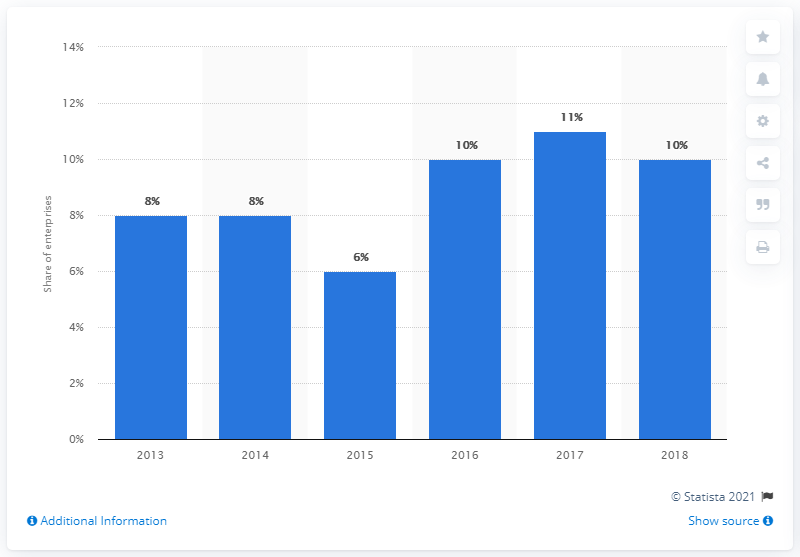Outline some significant characteristics in this image. In 2018, approximately 10% of businesses in Greece made B2C e-commerce sales through a website. 